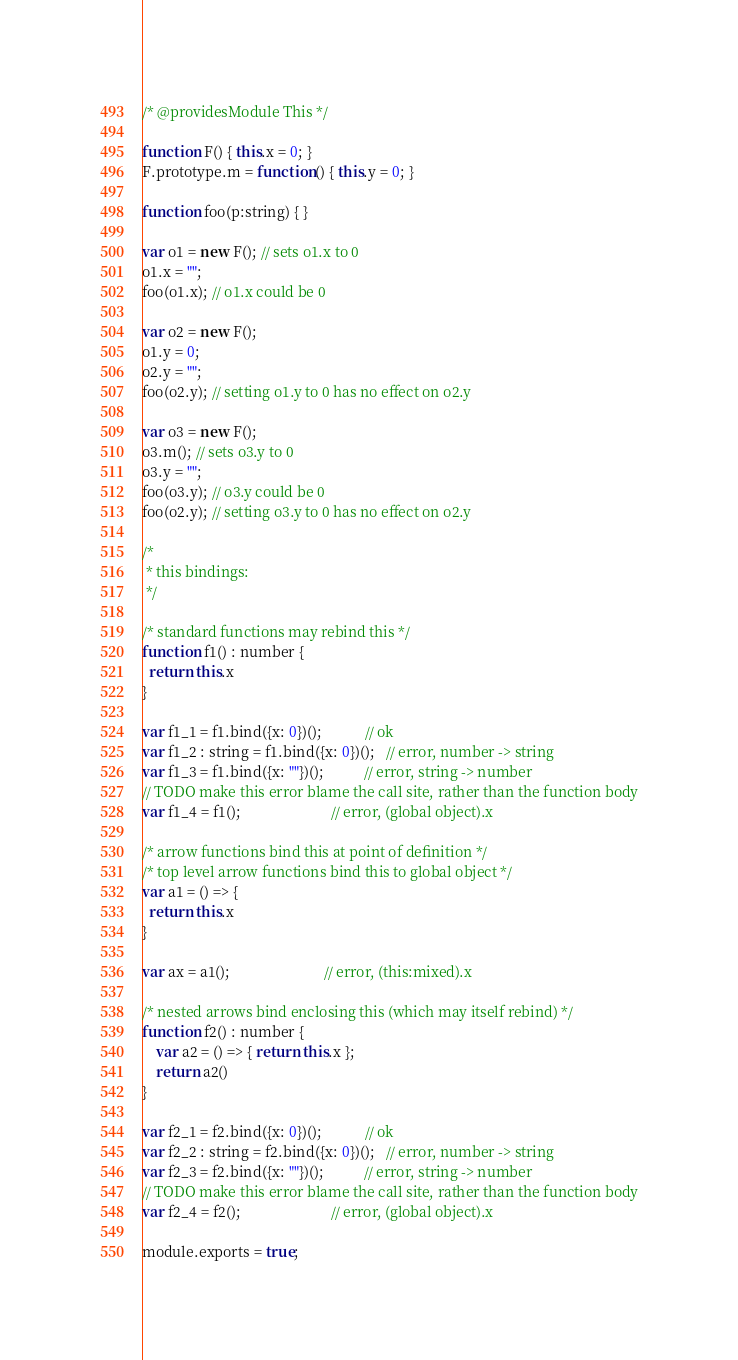<code> <loc_0><loc_0><loc_500><loc_500><_JavaScript_>/* @providesModule This */

function F() { this.x = 0; }
F.prototype.m = function() { this.y = 0; }

function foo(p:string) { }

var o1 = new F(); // sets o1.x to 0
o1.x = "";
foo(o1.x); // o1.x could be 0

var o2 = new F();
o1.y = 0;
o2.y = "";
foo(o2.y); // setting o1.y to 0 has no effect on o2.y

var o3 = new F();
o3.m(); // sets o3.y to 0
o3.y = "";
foo(o3.y); // o3.y could be 0
foo(o2.y); // setting o3.y to 0 has no effect on o2.y

/*
 * this bindings:
 */

/* standard functions may rebind this */
function f1() : number {
  return this.x
}

var f1_1 = f1.bind({x: 0})();            // ok
var f1_2 : string = f1.bind({x: 0})();   // error, number -> string
var f1_3 = f1.bind({x: ""})();           // error, string -> number
// TODO make this error blame the call site, rather than the function body
var f1_4 = f1();                         // error, (global object).x

/* arrow functions bind this at point of definition */
/* top level arrow functions bind this to global object */
var a1 = () => {
  return this.x
}

var ax = a1();                          // error, (this:mixed).x

/* nested arrows bind enclosing this (which may itself rebind) */
function f2() : number {
    var a2 = () => { return this.x };
    return a2()
}

var f2_1 = f2.bind({x: 0})();            // ok
var f2_2 : string = f2.bind({x: 0})();   // error, number -> string
var f2_3 = f2.bind({x: ""})();           // error, string -> number
// TODO make this error blame the call site, rather than the function body
var f2_4 = f2();                         // error, (global object).x

module.exports = true;
</code> 